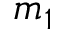<formula> <loc_0><loc_0><loc_500><loc_500>m _ { 1 }</formula> 